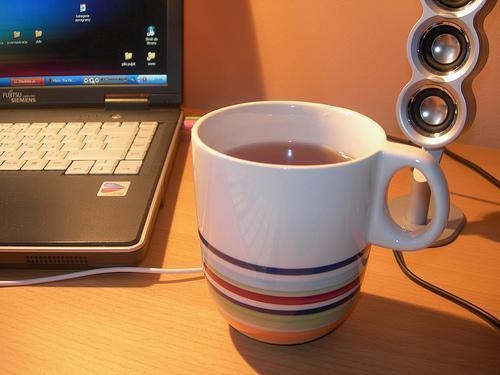How many cups are in the picture?
Give a very brief answer. 1. 